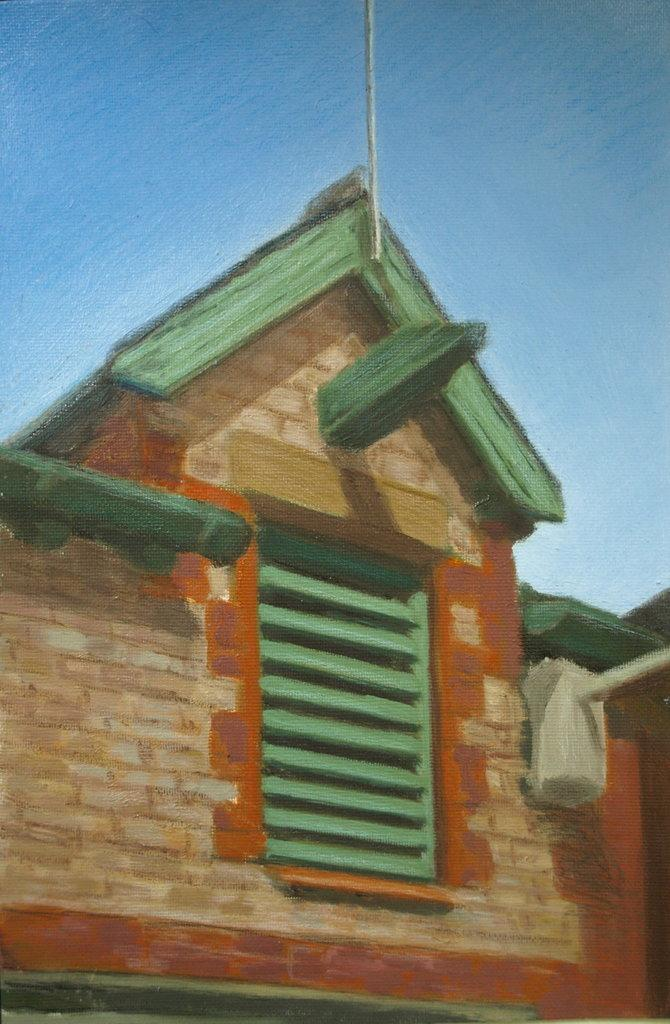What is the main subject of the painting in the image? The main subject of the painting in the image is a house. What color is used for the background of the painting? The background of the painting is in blue color. What type of advice is the house giving in the image? There is no indication in the image that the house is giving any advice, as it is a painting of a house and not a sentient being. 